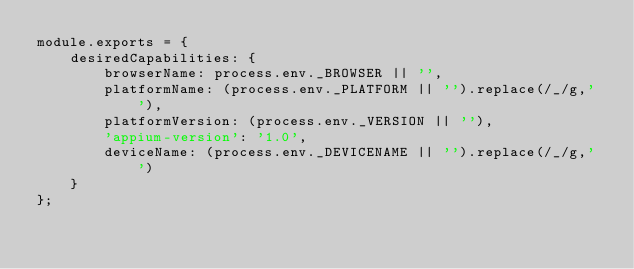Convert code to text. <code><loc_0><loc_0><loc_500><loc_500><_JavaScript_>module.exports = {
    desiredCapabilities: {
        browserName: process.env._BROWSER || '',
        platformName: (process.env._PLATFORM || '').replace(/_/g,' '),
        platformVersion: (process.env._VERSION || ''),
        'appium-version': '1.0',
        deviceName: (process.env._DEVICENAME || '').replace(/_/g,' ')
    }
};</code> 